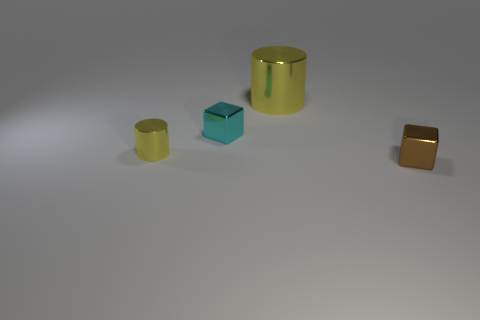Add 3 tiny blocks. How many objects exist? 7 Subtract 2 blocks. How many blocks are left? 0 Subtract all gray blocks. Subtract all purple cylinders. How many blocks are left? 2 Subtract all yellow cubes. How many blue cylinders are left? 0 Subtract all tiny yellow metal cylinders. Subtract all tiny yellow metal objects. How many objects are left? 2 Add 4 small yellow cylinders. How many small yellow cylinders are left? 5 Add 2 yellow shiny spheres. How many yellow shiny spheres exist? 2 Subtract all brown cubes. How many cubes are left? 1 Subtract 0 red blocks. How many objects are left? 4 